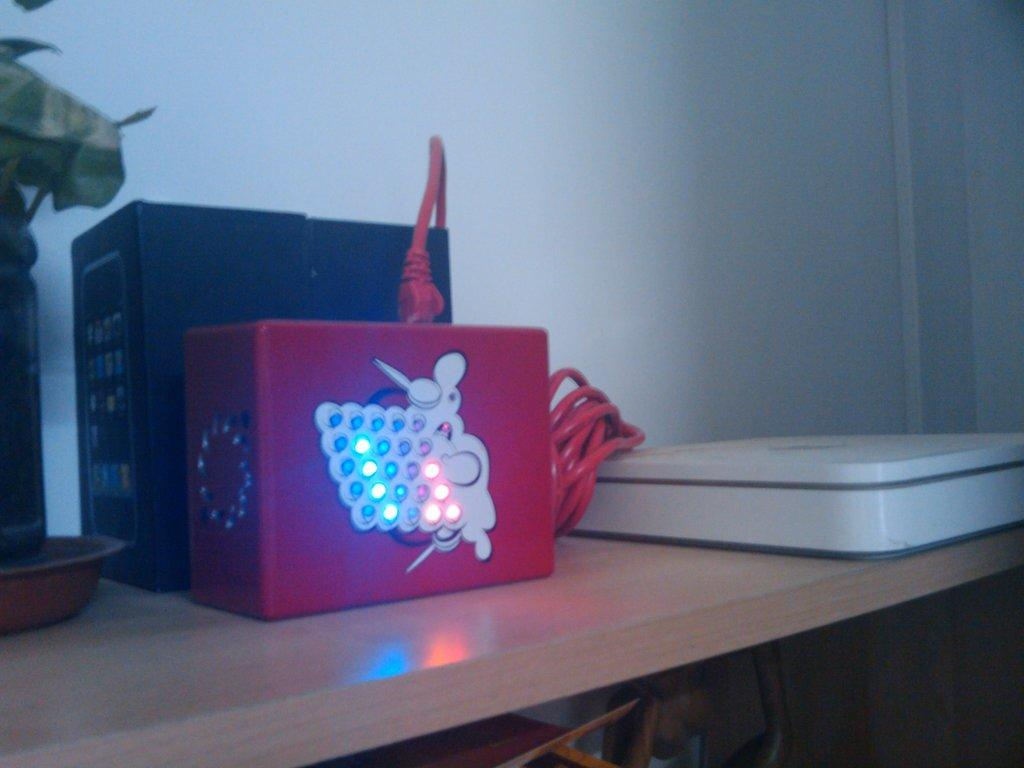What type of objects can be seen in the image in the image? There are electronic objects in the image. What is connected to the electronic objects? There is a cable in the image. What is an unusual item present in the image? There is a plant in a bottle in the image. How is the plant placed in the image? The plant is in a plate. What is the surface on which the objects are placed? The objects are on a wooden platform. What can be seen in the background of the image? There is a wall visible in the image. Are there any other objects in the image besides the electronic objects and the plant? Yes, there are other objects in the image. Can you tell me how many units of electricity the bee is generating in the image? There is no bee present in the image, and therefore no electricity generation can be observed. What type of kitty is sitting on the wooden platform in the image? There is no kitty present in the image. 